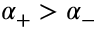Convert formula to latex. <formula><loc_0><loc_0><loc_500><loc_500>\alpha _ { + } > \alpha _ { - }</formula> 